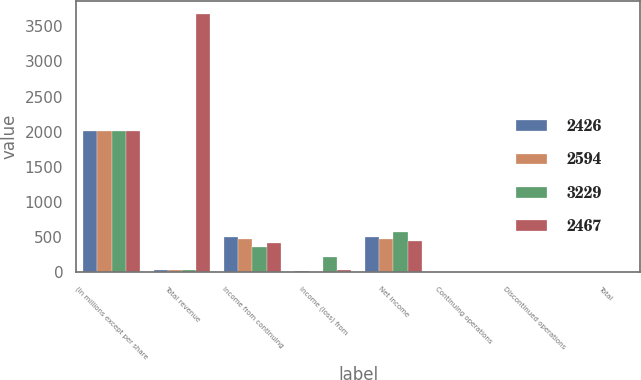Convert chart. <chart><loc_0><loc_0><loc_500><loc_500><stacked_bar_chart><ecel><fcel>(In millions except per share<fcel>Total revenue<fcel>Income from continuing<fcel>Income (loss) from<fcel>Net income<fcel>Continuing operations<fcel>Discontinued operations<fcel>Total<nl><fcel>2426<fcel>2010<fcel>27<fcel>506<fcel>10<fcel>496<fcel>3.37<fcel>0.07<fcel>3.3<nl><fcel>2594<fcel>2009<fcel>27<fcel>473<fcel>3<fcel>476<fcel>3.06<fcel>0.02<fcel>3.08<nl><fcel>3229<fcel>2008<fcel>27<fcel>358<fcel>211<fcel>569<fcel>2.21<fcel>1.3<fcel>3.51<nl><fcel>2467<fcel>2007<fcel>3677<fcel>412<fcel>27<fcel>439<fcel>2.47<fcel>0.16<fcel>2.64<nl></chart> 